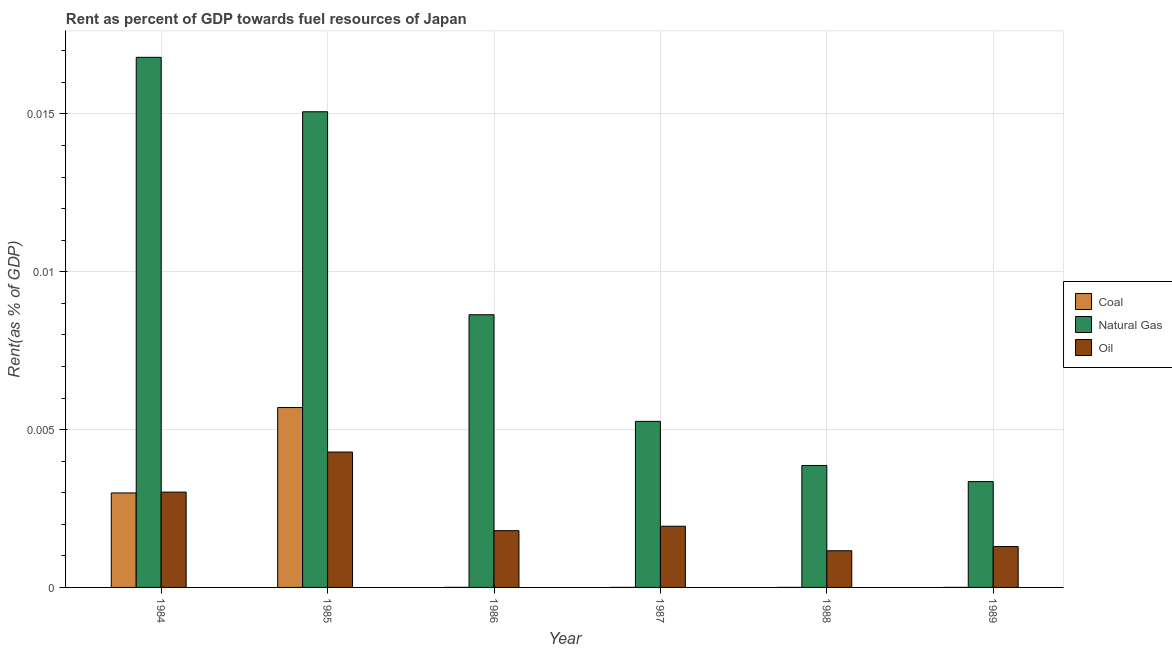How many different coloured bars are there?
Your answer should be very brief. 3. Are the number of bars per tick equal to the number of legend labels?
Keep it short and to the point. Yes. Are the number of bars on each tick of the X-axis equal?
Keep it short and to the point. Yes. How many bars are there on the 6th tick from the left?
Offer a terse response. 3. In how many cases, is the number of bars for a given year not equal to the number of legend labels?
Your answer should be very brief. 0. What is the rent towards coal in 1985?
Your answer should be compact. 0.01. Across all years, what is the maximum rent towards coal?
Ensure brevity in your answer.  0.01. Across all years, what is the minimum rent towards natural gas?
Provide a short and direct response. 0. In which year was the rent towards coal maximum?
Ensure brevity in your answer.  1985. What is the total rent towards oil in the graph?
Provide a succinct answer. 0.01. What is the difference between the rent towards natural gas in 1985 and that in 1986?
Provide a succinct answer. 0.01. What is the difference between the rent towards oil in 1987 and the rent towards coal in 1984?
Your response must be concise. -0. What is the average rent towards coal per year?
Your answer should be compact. 0. In the year 1989, what is the difference between the rent towards natural gas and rent towards coal?
Keep it short and to the point. 0. In how many years, is the rent towards coal greater than 0.006 %?
Ensure brevity in your answer.  0. What is the ratio of the rent towards natural gas in 1985 to that in 1988?
Your response must be concise. 3.9. Is the difference between the rent towards coal in 1987 and 1988 greater than the difference between the rent towards oil in 1987 and 1988?
Provide a short and direct response. No. What is the difference between the highest and the second highest rent towards natural gas?
Keep it short and to the point. 0. What is the difference between the highest and the lowest rent towards coal?
Keep it short and to the point. 0.01. Is the sum of the rent towards coal in 1987 and 1989 greater than the maximum rent towards oil across all years?
Your answer should be very brief. No. What does the 1st bar from the left in 1986 represents?
Give a very brief answer. Coal. What does the 2nd bar from the right in 1985 represents?
Ensure brevity in your answer.  Natural Gas. Is it the case that in every year, the sum of the rent towards coal and rent towards natural gas is greater than the rent towards oil?
Provide a short and direct response. Yes. How many bars are there?
Offer a very short reply. 18. How many years are there in the graph?
Give a very brief answer. 6. What is the difference between two consecutive major ticks on the Y-axis?
Give a very brief answer. 0.01. Are the values on the major ticks of Y-axis written in scientific E-notation?
Keep it short and to the point. No. Does the graph contain any zero values?
Provide a short and direct response. No. Does the graph contain grids?
Provide a succinct answer. Yes. How many legend labels are there?
Give a very brief answer. 3. How are the legend labels stacked?
Provide a succinct answer. Vertical. What is the title of the graph?
Provide a succinct answer. Rent as percent of GDP towards fuel resources of Japan. What is the label or title of the X-axis?
Ensure brevity in your answer.  Year. What is the label or title of the Y-axis?
Provide a short and direct response. Rent(as % of GDP). What is the Rent(as % of GDP) in Coal in 1984?
Offer a very short reply. 0. What is the Rent(as % of GDP) in Natural Gas in 1984?
Make the answer very short. 0.02. What is the Rent(as % of GDP) of Oil in 1984?
Provide a short and direct response. 0. What is the Rent(as % of GDP) of Coal in 1985?
Your answer should be compact. 0.01. What is the Rent(as % of GDP) in Natural Gas in 1985?
Offer a terse response. 0.02. What is the Rent(as % of GDP) of Oil in 1985?
Provide a short and direct response. 0. What is the Rent(as % of GDP) of Coal in 1986?
Your answer should be compact. 2.58321740382943e-6. What is the Rent(as % of GDP) in Natural Gas in 1986?
Give a very brief answer. 0.01. What is the Rent(as % of GDP) of Oil in 1986?
Keep it short and to the point. 0. What is the Rent(as % of GDP) of Coal in 1987?
Make the answer very short. 9.41219772852493e-7. What is the Rent(as % of GDP) of Natural Gas in 1987?
Your answer should be very brief. 0.01. What is the Rent(as % of GDP) in Oil in 1987?
Your response must be concise. 0. What is the Rent(as % of GDP) in Coal in 1988?
Keep it short and to the point. 1.04103269481031e-6. What is the Rent(as % of GDP) in Natural Gas in 1988?
Ensure brevity in your answer.  0. What is the Rent(as % of GDP) in Oil in 1988?
Keep it short and to the point. 0. What is the Rent(as % of GDP) in Coal in 1989?
Give a very brief answer. 1.52673685827782e-6. What is the Rent(as % of GDP) of Natural Gas in 1989?
Your response must be concise. 0. What is the Rent(as % of GDP) of Oil in 1989?
Give a very brief answer. 0. Across all years, what is the maximum Rent(as % of GDP) in Coal?
Provide a succinct answer. 0.01. Across all years, what is the maximum Rent(as % of GDP) in Natural Gas?
Provide a succinct answer. 0.02. Across all years, what is the maximum Rent(as % of GDP) of Oil?
Keep it short and to the point. 0. Across all years, what is the minimum Rent(as % of GDP) in Coal?
Keep it short and to the point. 9.41219772852493e-7. Across all years, what is the minimum Rent(as % of GDP) of Natural Gas?
Ensure brevity in your answer.  0. Across all years, what is the minimum Rent(as % of GDP) in Oil?
Give a very brief answer. 0. What is the total Rent(as % of GDP) of Coal in the graph?
Offer a very short reply. 0.01. What is the total Rent(as % of GDP) in Natural Gas in the graph?
Your response must be concise. 0.05. What is the total Rent(as % of GDP) of Oil in the graph?
Keep it short and to the point. 0.01. What is the difference between the Rent(as % of GDP) of Coal in 1984 and that in 1985?
Provide a short and direct response. -0. What is the difference between the Rent(as % of GDP) of Natural Gas in 1984 and that in 1985?
Provide a succinct answer. 0. What is the difference between the Rent(as % of GDP) of Oil in 1984 and that in 1985?
Keep it short and to the point. -0. What is the difference between the Rent(as % of GDP) in Coal in 1984 and that in 1986?
Make the answer very short. 0. What is the difference between the Rent(as % of GDP) of Natural Gas in 1984 and that in 1986?
Your response must be concise. 0.01. What is the difference between the Rent(as % of GDP) in Oil in 1984 and that in 1986?
Make the answer very short. 0. What is the difference between the Rent(as % of GDP) of Coal in 1984 and that in 1987?
Your response must be concise. 0. What is the difference between the Rent(as % of GDP) in Natural Gas in 1984 and that in 1987?
Keep it short and to the point. 0.01. What is the difference between the Rent(as % of GDP) of Oil in 1984 and that in 1987?
Give a very brief answer. 0. What is the difference between the Rent(as % of GDP) of Coal in 1984 and that in 1988?
Give a very brief answer. 0. What is the difference between the Rent(as % of GDP) of Natural Gas in 1984 and that in 1988?
Your answer should be very brief. 0.01. What is the difference between the Rent(as % of GDP) of Oil in 1984 and that in 1988?
Your answer should be compact. 0. What is the difference between the Rent(as % of GDP) of Coal in 1984 and that in 1989?
Your response must be concise. 0. What is the difference between the Rent(as % of GDP) in Natural Gas in 1984 and that in 1989?
Give a very brief answer. 0.01. What is the difference between the Rent(as % of GDP) in Oil in 1984 and that in 1989?
Your answer should be very brief. 0. What is the difference between the Rent(as % of GDP) in Coal in 1985 and that in 1986?
Provide a short and direct response. 0.01. What is the difference between the Rent(as % of GDP) of Natural Gas in 1985 and that in 1986?
Provide a short and direct response. 0.01. What is the difference between the Rent(as % of GDP) in Oil in 1985 and that in 1986?
Ensure brevity in your answer.  0. What is the difference between the Rent(as % of GDP) of Coal in 1985 and that in 1987?
Your answer should be compact. 0.01. What is the difference between the Rent(as % of GDP) in Natural Gas in 1985 and that in 1987?
Your response must be concise. 0.01. What is the difference between the Rent(as % of GDP) of Oil in 1985 and that in 1987?
Offer a very short reply. 0. What is the difference between the Rent(as % of GDP) in Coal in 1985 and that in 1988?
Your response must be concise. 0.01. What is the difference between the Rent(as % of GDP) in Natural Gas in 1985 and that in 1988?
Your answer should be very brief. 0.01. What is the difference between the Rent(as % of GDP) in Oil in 1985 and that in 1988?
Provide a succinct answer. 0. What is the difference between the Rent(as % of GDP) in Coal in 1985 and that in 1989?
Keep it short and to the point. 0.01. What is the difference between the Rent(as % of GDP) in Natural Gas in 1985 and that in 1989?
Offer a terse response. 0.01. What is the difference between the Rent(as % of GDP) of Oil in 1985 and that in 1989?
Make the answer very short. 0. What is the difference between the Rent(as % of GDP) in Natural Gas in 1986 and that in 1987?
Offer a very short reply. 0. What is the difference between the Rent(as % of GDP) in Oil in 1986 and that in 1987?
Offer a terse response. -0. What is the difference between the Rent(as % of GDP) in Coal in 1986 and that in 1988?
Make the answer very short. 0. What is the difference between the Rent(as % of GDP) in Natural Gas in 1986 and that in 1988?
Provide a short and direct response. 0. What is the difference between the Rent(as % of GDP) in Oil in 1986 and that in 1988?
Ensure brevity in your answer.  0. What is the difference between the Rent(as % of GDP) of Coal in 1986 and that in 1989?
Your answer should be compact. 0. What is the difference between the Rent(as % of GDP) in Natural Gas in 1986 and that in 1989?
Your answer should be very brief. 0.01. What is the difference between the Rent(as % of GDP) in Natural Gas in 1987 and that in 1988?
Your answer should be compact. 0. What is the difference between the Rent(as % of GDP) in Oil in 1987 and that in 1988?
Your answer should be compact. 0. What is the difference between the Rent(as % of GDP) of Natural Gas in 1987 and that in 1989?
Your answer should be very brief. 0. What is the difference between the Rent(as % of GDP) of Oil in 1987 and that in 1989?
Keep it short and to the point. 0. What is the difference between the Rent(as % of GDP) in Coal in 1988 and that in 1989?
Give a very brief answer. -0. What is the difference between the Rent(as % of GDP) of Oil in 1988 and that in 1989?
Offer a terse response. -0. What is the difference between the Rent(as % of GDP) in Coal in 1984 and the Rent(as % of GDP) in Natural Gas in 1985?
Keep it short and to the point. -0.01. What is the difference between the Rent(as % of GDP) in Coal in 1984 and the Rent(as % of GDP) in Oil in 1985?
Give a very brief answer. -0. What is the difference between the Rent(as % of GDP) of Natural Gas in 1984 and the Rent(as % of GDP) of Oil in 1985?
Make the answer very short. 0.01. What is the difference between the Rent(as % of GDP) in Coal in 1984 and the Rent(as % of GDP) in Natural Gas in 1986?
Give a very brief answer. -0.01. What is the difference between the Rent(as % of GDP) of Coal in 1984 and the Rent(as % of GDP) of Oil in 1986?
Provide a succinct answer. 0. What is the difference between the Rent(as % of GDP) in Natural Gas in 1984 and the Rent(as % of GDP) in Oil in 1986?
Your response must be concise. 0.01. What is the difference between the Rent(as % of GDP) in Coal in 1984 and the Rent(as % of GDP) in Natural Gas in 1987?
Your answer should be very brief. -0. What is the difference between the Rent(as % of GDP) of Coal in 1984 and the Rent(as % of GDP) of Oil in 1987?
Ensure brevity in your answer.  0. What is the difference between the Rent(as % of GDP) in Natural Gas in 1984 and the Rent(as % of GDP) in Oil in 1987?
Provide a short and direct response. 0.01. What is the difference between the Rent(as % of GDP) of Coal in 1984 and the Rent(as % of GDP) of Natural Gas in 1988?
Keep it short and to the point. -0. What is the difference between the Rent(as % of GDP) in Coal in 1984 and the Rent(as % of GDP) in Oil in 1988?
Ensure brevity in your answer.  0. What is the difference between the Rent(as % of GDP) of Natural Gas in 1984 and the Rent(as % of GDP) of Oil in 1988?
Give a very brief answer. 0.02. What is the difference between the Rent(as % of GDP) in Coal in 1984 and the Rent(as % of GDP) in Natural Gas in 1989?
Your answer should be compact. -0. What is the difference between the Rent(as % of GDP) of Coal in 1984 and the Rent(as % of GDP) of Oil in 1989?
Provide a short and direct response. 0. What is the difference between the Rent(as % of GDP) in Natural Gas in 1984 and the Rent(as % of GDP) in Oil in 1989?
Provide a succinct answer. 0.02. What is the difference between the Rent(as % of GDP) in Coal in 1985 and the Rent(as % of GDP) in Natural Gas in 1986?
Offer a very short reply. -0. What is the difference between the Rent(as % of GDP) of Coal in 1985 and the Rent(as % of GDP) of Oil in 1986?
Your answer should be very brief. 0. What is the difference between the Rent(as % of GDP) of Natural Gas in 1985 and the Rent(as % of GDP) of Oil in 1986?
Make the answer very short. 0.01. What is the difference between the Rent(as % of GDP) in Coal in 1985 and the Rent(as % of GDP) in Natural Gas in 1987?
Make the answer very short. 0. What is the difference between the Rent(as % of GDP) of Coal in 1985 and the Rent(as % of GDP) of Oil in 1987?
Keep it short and to the point. 0. What is the difference between the Rent(as % of GDP) of Natural Gas in 1985 and the Rent(as % of GDP) of Oil in 1987?
Your response must be concise. 0.01. What is the difference between the Rent(as % of GDP) in Coal in 1985 and the Rent(as % of GDP) in Natural Gas in 1988?
Offer a terse response. 0. What is the difference between the Rent(as % of GDP) in Coal in 1985 and the Rent(as % of GDP) in Oil in 1988?
Provide a succinct answer. 0. What is the difference between the Rent(as % of GDP) in Natural Gas in 1985 and the Rent(as % of GDP) in Oil in 1988?
Keep it short and to the point. 0.01. What is the difference between the Rent(as % of GDP) of Coal in 1985 and the Rent(as % of GDP) of Natural Gas in 1989?
Your answer should be very brief. 0. What is the difference between the Rent(as % of GDP) of Coal in 1985 and the Rent(as % of GDP) of Oil in 1989?
Your answer should be compact. 0. What is the difference between the Rent(as % of GDP) of Natural Gas in 1985 and the Rent(as % of GDP) of Oil in 1989?
Provide a succinct answer. 0.01. What is the difference between the Rent(as % of GDP) of Coal in 1986 and the Rent(as % of GDP) of Natural Gas in 1987?
Provide a succinct answer. -0.01. What is the difference between the Rent(as % of GDP) in Coal in 1986 and the Rent(as % of GDP) in Oil in 1987?
Make the answer very short. -0. What is the difference between the Rent(as % of GDP) in Natural Gas in 1986 and the Rent(as % of GDP) in Oil in 1987?
Make the answer very short. 0.01. What is the difference between the Rent(as % of GDP) of Coal in 1986 and the Rent(as % of GDP) of Natural Gas in 1988?
Provide a short and direct response. -0. What is the difference between the Rent(as % of GDP) in Coal in 1986 and the Rent(as % of GDP) in Oil in 1988?
Your answer should be compact. -0. What is the difference between the Rent(as % of GDP) of Natural Gas in 1986 and the Rent(as % of GDP) of Oil in 1988?
Your answer should be very brief. 0.01. What is the difference between the Rent(as % of GDP) of Coal in 1986 and the Rent(as % of GDP) of Natural Gas in 1989?
Keep it short and to the point. -0. What is the difference between the Rent(as % of GDP) of Coal in 1986 and the Rent(as % of GDP) of Oil in 1989?
Offer a very short reply. -0. What is the difference between the Rent(as % of GDP) in Natural Gas in 1986 and the Rent(as % of GDP) in Oil in 1989?
Make the answer very short. 0.01. What is the difference between the Rent(as % of GDP) in Coal in 1987 and the Rent(as % of GDP) in Natural Gas in 1988?
Your answer should be compact. -0. What is the difference between the Rent(as % of GDP) in Coal in 1987 and the Rent(as % of GDP) in Oil in 1988?
Ensure brevity in your answer.  -0. What is the difference between the Rent(as % of GDP) in Natural Gas in 1987 and the Rent(as % of GDP) in Oil in 1988?
Offer a terse response. 0. What is the difference between the Rent(as % of GDP) of Coal in 1987 and the Rent(as % of GDP) of Natural Gas in 1989?
Provide a succinct answer. -0. What is the difference between the Rent(as % of GDP) of Coal in 1987 and the Rent(as % of GDP) of Oil in 1989?
Make the answer very short. -0. What is the difference between the Rent(as % of GDP) in Natural Gas in 1987 and the Rent(as % of GDP) in Oil in 1989?
Ensure brevity in your answer.  0. What is the difference between the Rent(as % of GDP) in Coal in 1988 and the Rent(as % of GDP) in Natural Gas in 1989?
Make the answer very short. -0. What is the difference between the Rent(as % of GDP) in Coal in 1988 and the Rent(as % of GDP) in Oil in 1989?
Provide a succinct answer. -0. What is the difference between the Rent(as % of GDP) in Natural Gas in 1988 and the Rent(as % of GDP) in Oil in 1989?
Your answer should be compact. 0. What is the average Rent(as % of GDP) of Coal per year?
Offer a terse response. 0. What is the average Rent(as % of GDP) of Natural Gas per year?
Offer a very short reply. 0.01. What is the average Rent(as % of GDP) of Oil per year?
Provide a short and direct response. 0. In the year 1984, what is the difference between the Rent(as % of GDP) of Coal and Rent(as % of GDP) of Natural Gas?
Your response must be concise. -0.01. In the year 1984, what is the difference between the Rent(as % of GDP) of Coal and Rent(as % of GDP) of Oil?
Keep it short and to the point. -0. In the year 1984, what is the difference between the Rent(as % of GDP) of Natural Gas and Rent(as % of GDP) of Oil?
Your answer should be compact. 0.01. In the year 1985, what is the difference between the Rent(as % of GDP) in Coal and Rent(as % of GDP) in Natural Gas?
Your response must be concise. -0.01. In the year 1985, what is the difference between the Rent(as % of GDP) of Coal and Rent(as % of GDP) of Oil?
Your answer should be compact. 0. In the year 1985, what is the difference between the Rent(as % of GDP) of Natural Gas and Rent(as % of GDP) of Oil?
Ensure brevity in your answer.  0.01. In the year 1986, what is the difference between the Rent(as % of GDP) in Coal and Rent(as % of GDP) in Natural Gas?
Give a very brief answer. -0.01. In the year 1986, what is the difference between the Rent(as % of GDP) of Coal and Rent(as % of GDP) of Oil?
Offer a very short reply. -0. In the year 1986, what is the difference between the Rent(as % of GDP) of Natural Gas and Rent(as % of GDP) of Oil?
Offer a very short reply. 0.01. In the year 1987, what is the difference between the Rent(as % of GDP) in Coal and Rent(as % of GDP) in Natural Gas?
Your answer should be very brief. -0.01. In the year 1987, what is the difference between the Rent(as % of GDP) in Coal and Rent(as % of GDP) in Oil?
Offer a very short reply. -0. In the year 1987, what is the difference between the Rent(as % of GDP) in Natural Gas and Rent(as % of GDP) in Oil?
Keep it short and to the point. 0. In the year 1988, what is the difference between the Rent(as % of GDP) in Coal and Rent(as % of GDP) in Natural Gas?
Your answer should be compact. -0. In the year 1988, what is the difference between the Rent(as % of GDP) of Coal and Rent(as % of GDP) of Oil?
Your response must be concise. -0. In the year 1988, what is the difference between the Rent(as % of GDP) in Natural Gas and Rent(as % of GDP) in Oil?
Make the answer very short. 0. In the year 1989, what is the difference between the Rent(as % of GDP) of Coal and Rent(as % of GDP) of Natural Gas?
Offer a terse response. -0. In the year 1989, what is the difference between the Rent(as % of GDP) in Coal and Rent(as % of GDP) in Oil?
Provide a succinct answer. -0. In the year 1989, what is the difference between the Rent(as % of GDP) of Natural Gas and Rent(as % of GDP) of Oil?
Your answer should be compact. 0. What is the ratio of the Rent(as % of GDP) in Coal in 1984 to that in 1985?
Keep it short and to the point. 0.53. What is the ratio of the Rent(as % of GDP) of Natural Gas in 1984 to that in 1985?
Make the answer very short. 1.11. What is the ratio of the Rent(as % of GDP) in Oil in 1984 to that in 1985?
Provide a succinct answer. 0.7. What is the ratio of the Rent(as % of GDP) in Coal in 1984 to that in 1986?
Your response must be concise. 1158.89. What is the ratio of the Rent(as % of GDP) in Natural Gas in 1984 to that in 1986?
Give a very brief answer. 1.94. What is the ratio of the Rent(as % of GDP) of Oil in 1984 to that in 1986?
Keep it short and to the point. 1.68. What is the ratio of the Rent(as % of GDP) of Coal in 1984 to that in 1987?
Offer a terse response. 3180.62. What is the ratio of the Rent(as % of GDP) of Natural Gas in 1984 to that in 1987?
Provide a succinct answer. 3.19. What is the ratio of the Rent(as % of GDP) in Oil in 1984 to that in 1987?
Your response must be concise. 1.56. What is the ratio of the Rent(as % of GDP) in Coal in 1984 to that in 1988?
Offer a very short reply. 2875.67. What is the ratio of the Rent(as % of GDP) of Natural Gas in 1984 to that in 1988?
Give a very brief answer. 4.35. What is the ratio of the Rent(as % of GDP) in Oil in 1984 to that in 1988?
Keep it short and to the point. 2.6. What is the ratio of the Rent(as % of GDP) of Coal in 1984 to that in 1989?
Keep it short and to the point. 1960.82. What is the ratio of the Rent(as % of GDP) of Natural Gas in 1984 to that in 1989?
Give a very brief answer. 5.01. What is the ratio of the Rent(as % of GDP) in Oil in 1984 to that in 1989?
Make the answer very short. 2.33. What is the ratio of the Rent(as % of GDP) of Coal in 1985 to that in 1986?
Provide a succinct answer. 2206.31. What is the ratio of the Rent(as % of GDP) in Natural Gas in 1985 to that in 1986?
Offer a very short reply. 1.74. What is the ratio of the Rent(as % of GDP) in Oil in 1985 to that in 1986?
Offer a very short reply. 2.39. What is the ratio of the Rent(as % of GDP) in Coal in 1985 to that in 1987?
Your answer should be very brief. 6055.3. What is the ratio of the Rent(as % of GDP) in Natural Gas in 1985 to that in 1987?
Make the answer very short. 2.86. What is the ratio of the Rent(as % of GDP) in Oil in 1985 to that in 1987?
Your answer should be very brief. 2.21. What is the ratio of the Rent(as % of GDP) in Coal in 1985 to that in 1988?
Your response must be concise. 5474.73. What is the ratio of the Rent(as % of GDP) in Natural Gas in 1985 to that in 1988?
Make the answer very short. 3.9. What is the ratio of the Rent(as % of GDP) of Oil in 1985 to that in 1988?
Keep it short and to the point. 3.69. What is the ratio of the Rent(as % of GDP) of Coal in 1985 to that in 1989?
Offer a terse response. 3733.04. What is the ratio of the Rent(as % of GDP) of Natural Gas in 1985 to that in 1989?
Give a very brief answer. 4.5. What is the ratio of the Rent(as % of GDP) of Oil in 1985 to that in 1989?
Provide a succinct answer. 3.31. What is the ratio of the Rent(as % of GDP) of Coal in 1986 to that in 1987?
Ensure brevity in your answer.  2.74. What is the ratio of the Rent(as % of GDP) of Natural Gas in 1986 to that in 1987?
Keep it short and to the point. 1.64. What is the ratio of the Rent(as % of GDP) of Oil in 1986 to that in 1987?
Keep it short and to the point. 0.93. What is the ratio of the Rent(as % of GDP) of Coal in 1986 to that in 1988?
Make the answer very short. 2.48. What is the ratio of the Rent(as % of GDP) of Natural Gas in 1986 to that in 1988?
Ensure brevity in your answer.  2.24. What is the ratio of the Rent(as % of GDP) in Oil in 1986 to that in 1988?
Offer a terse response. 1.55. What is the ratio of the Rent(as % of GDP) in Coal in 1986 to that in 1989?
Provide a short and direct response. 1.69. What is the ratio of the Rent(as % of GDP) in Natural Gas in 1986 to that in 1989?
Provide a succinct answer. 2.58. What is the ratio of the Rent(as % of GDP) in Oil in 1986 to that in 1989?
Keep it short and to the point. 1.39. What is the ratio of the Rent(as % of GDP) in Coal in 1987 to that in 1988?
Offer a very short reply. 0.9. What is the ratio of the Rent(as % of GDP) in Natural Gas in 1987 to that in 1988?
Ensure brevity in your answer.  1.36. What is the ratio of the Rent(as % of GDP) of Oil in 1987 to that in 1988?
Ensure brevity in your answer.  1.67. What is the ratio of the Rent(as % of GDP) in Coal in 1987 to that in 1989?
Offer a terse response. 0.62. What is the ratio of the Rent(as % of GDP) of Natural Gas in 1987 to that in 1989?
Give a very brief answer. 1.57. What is the ratio of the Rent(as % of GDP) of Oil in 1987 to that in 1989?
Make the answer very short. 1.5. What is the ratio of the Rent(as % of GDP) of Coal in 1988 to that in 1989?
Your response must be concise. 0.68. What is the ratio of the Rent(as % of GDP) of Natural Gas in 1988 to that in 1989?
Your response must be concise. 1.15. What is the ratio of the Rent(as % of GDP) in Oil in 1988 to that in 1989?
Give a very brief answer. 0.9. What is the difference between the highest and the second highest Rent(as % of GDP) of Coal?
Give a very brief answer. 0. What is the difference between the highest and the second highest Rent(as % of GDP) of Natural Gas?
Provide a succinct answer. 0. What is the difference between the highest and the second highest Rent(as % of GDP) in Oil?
Provide a succinct answer. 0. What is the difference between the highest and the lowest Rent(as % of GDP) of Coal?
Make the answer very short. 0.01. What is the difference between the highest and the lowest Rent(as % of GDP) in Natural Gas?
Make the answer very short. 0.01. What is the difference between the highest and the lowest Rent(as % of GDP) of Oil?
Your answer should be compact. 0. 